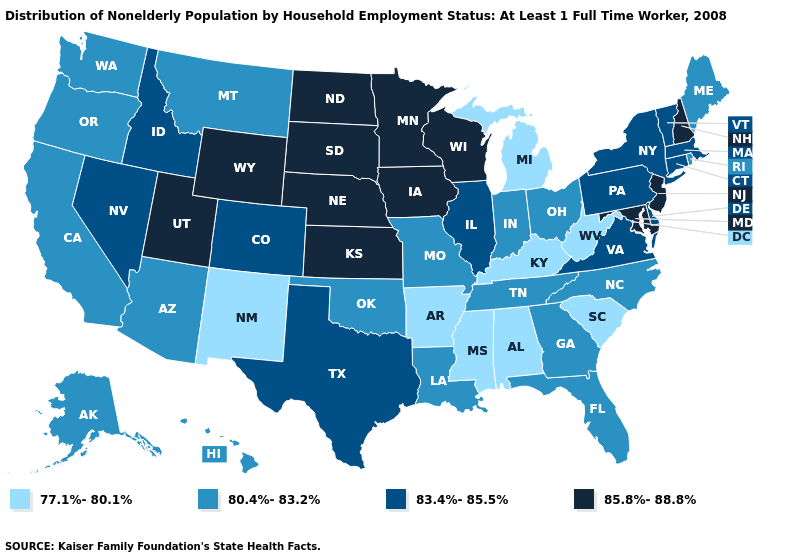What is the value of West Virginia?
Write a very short answer. 77.1%-80.1%. What is the value of Arkansas?
Answer briefly. 77.1%-80.1%. What is the value of Arkansas?
Answer briefly. 77.1%-80.1%. Which states hav the highest value in the Northeast?
Write a very short answer. New Hampshire, New Jersey. Does Maine have a higher value than Florida?
Give a very brief answer. No. What is the lowest value in the Northeast?
Quick response, please. 80.4%-83.2%. What is the highest value in the USA?
Give a very brief answer. 85.8%-88.8%. What is the value of Louisiana?
Give a very brief answer. 80.4%-83.2%. Which states have the lowest value in the USA?
Be succinct. Alabama, Arkansas, Kentucky, Michigan, Mississippi, New Mexico, South Carolina, West Virginia. Name the states that have a value in the range 85.8%-88.8%?
Short answer required. Iowa, Kansas, Maryland, Minnesota, Nebraska, New Hampshire, New Jersey, North Dakota, South Dakota, Utah, Wisconsin, Wyoming. Does Maryland have the highest value in the South?
Give a very brief answer. Yes. Does the first symbol in the legend represent the smallest category?
Be succinct. Yes. Among the states that border West Virginia , which have the lowest value?
Short answer required. Kentucky. What is the value of Montana?
Concise answer only. 80.4%-83.2%. Is the legend a continuous bar?
Concise answer only. No. 